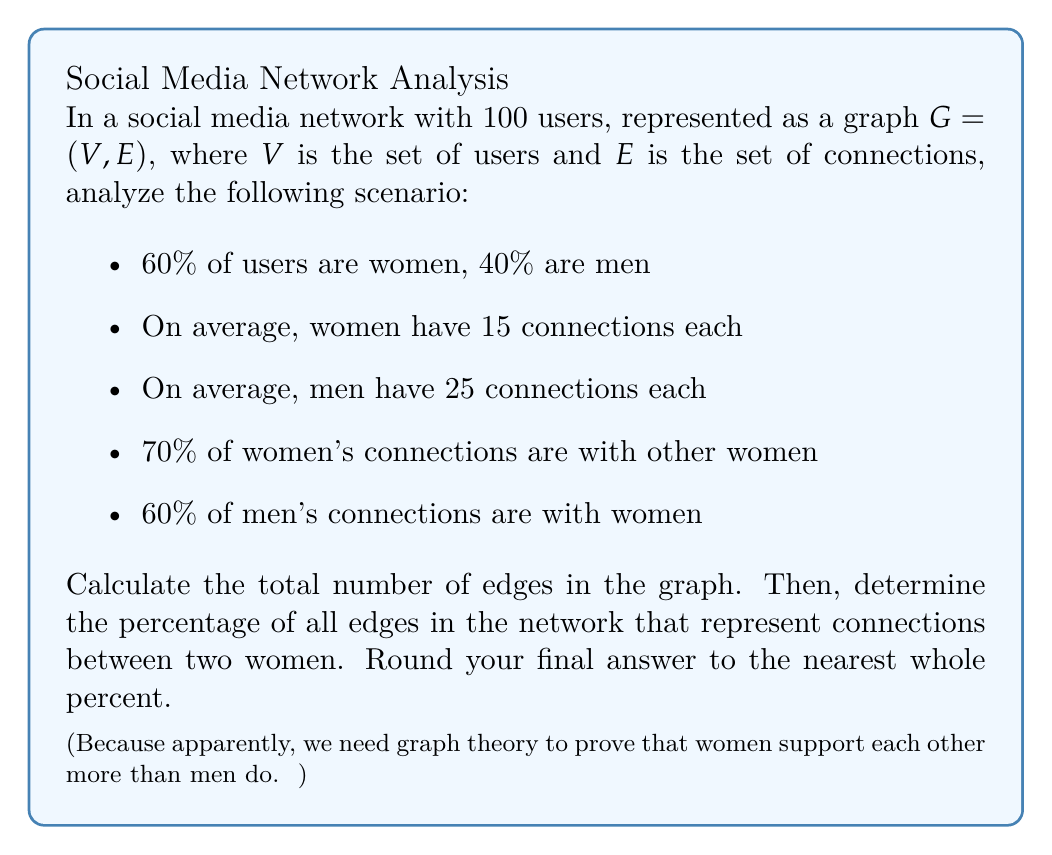Give your solution to this math problem. Let's break this down step-by-step:

1) First, let's identify the number of users:
   Women: $0.60 \times 100 = 60$
   Men: $0.40 \times 100 = 40$

2) Calculate the total number of connections for women:
   $60 \text{ women} \times 15 \text{ connections} = 900 \text{ connections}$

3) Calculate the total number of connections for men:
   $40 \text{ men} \times 25 \text{ connections} = 1000 \text{ connections}$

4) Total connections in the network:
   $900 + 1000 = 1900 \text{ connections}$

5) However, each connection is counted twice (once for each user it connects), so the actual number of edges is:
   $\text{Total edges} = 1900 \div 2 = 950$

6) Now, let's calculate the number of woman-to-woman connections:
   $70\% \text{ of women's connections} = 0.70 \times 900 = 630 \text{ connections}$

7) Again, these connections are counted twice, so the actual number of woman-to-woman edges is:
   $\text{Woman-to-woman edges} = 630 \div 2 = 315$

8) Calculate the percentage:
   $$\text{Percentage} = \frac{\text{Woman-to-woman edges}}{\text{Total edges}} \times 100\% = \frac{315}{950} \times 100\% \approx 33.16\%$$

9) Rounding to the nearest whole percent: 33%
Answer: 33% 